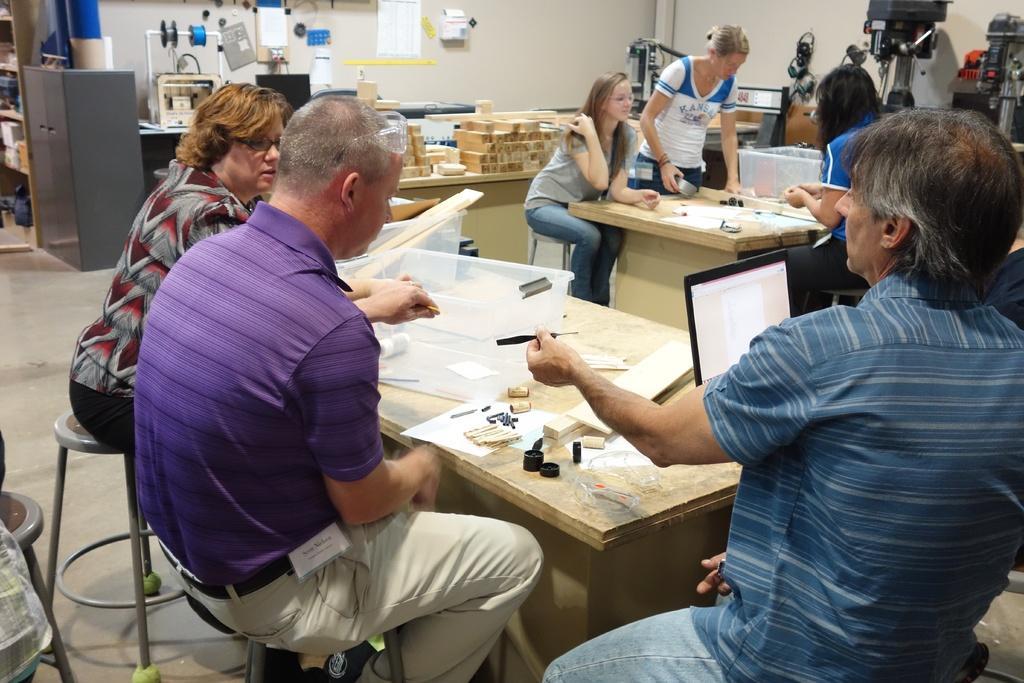Could you give a brief overview of what you see in this image? In the image we can see there are people who are sitting on a chair in front of them there is a table and there is a laptop and at the back there is a wooden logs on the table and there is a almera over here. 